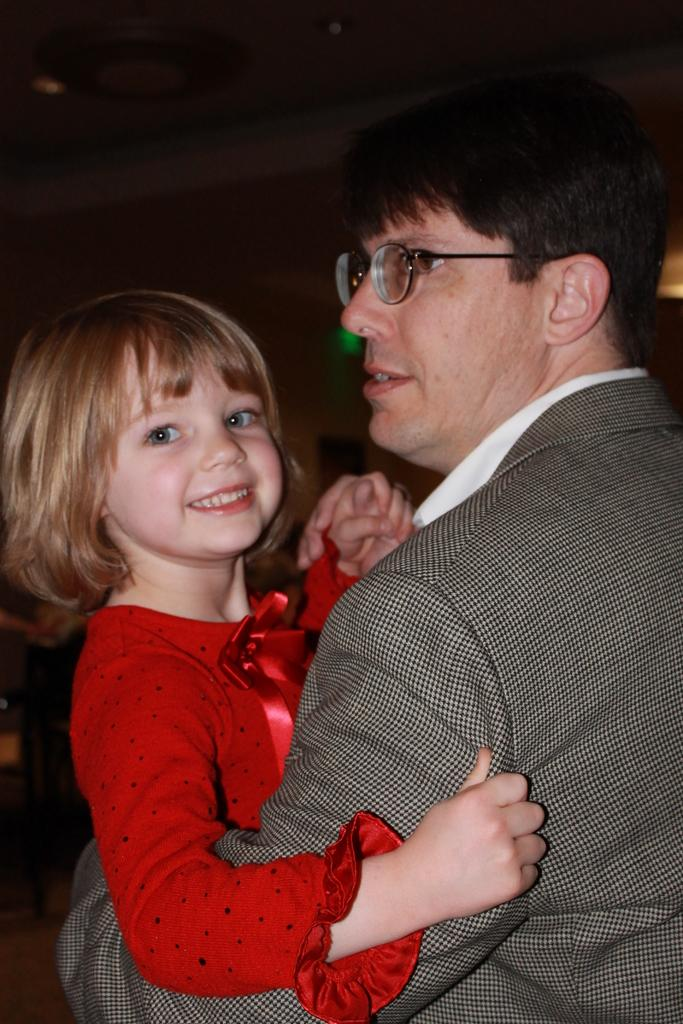Who is the main subject in the image? The main subject in the image is a man. What is the man wearing? The man is wearing a suit. What is the man doing in the image? The man is holding a child. What is the child wearing? The child is wearing a red dress. What is the child's expression in the image? The child is smiling. What accessory is the man wearing? The man is wearing spectacles. What type of sack can be seen in the image? There is no sack present in the image. What is the weight of the child on the scale in the image? There is no scale present in the image. 